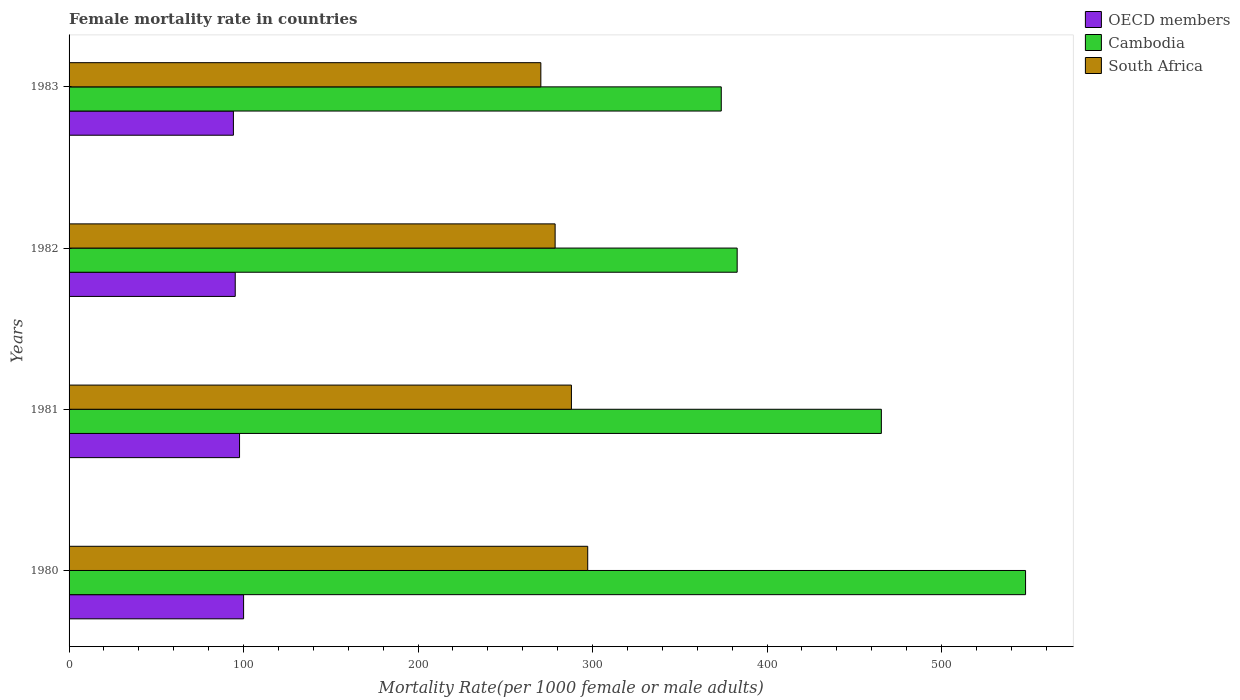Are the number of bars per tick equal to the number of legend labels?
Your answer should be compact. Yes. Are the number of bars on each tick of the Y-axis equal?
Offer a terse response. Yes. What is the label of the 2nd group of bars from the top?
Ensure brevity in your answer.  1982. In how many cases, is the number of bars for a given year not equal to the number of legend labels?
Offer a terse response. 0. What is the female mortality rate in Cambodia in 1983?
Your answer should be very brief. 373.76. Across all years, what is the maximum female mortality rate in South Africa?
Your answer should be compact. 297.23. Across all years, what is the minimum female mortality rate in Cambodia?
Provide a short and direct response. 373.76. What is the total female mortality rate in South Africa in the graph?
Give a very brief answer. 1134.04. What is the difference between the female mortality rate in South Africa in 1981 and that in 1982?
Provide a short and direct response. 9.34. What is the difference between the female mortality rate in South Africa in 1981 and the female mortality rate in Cambodia in 1982?
Give a very brief answer. -94.98. What is the average female mortality rate in South Africa per year?
Give a very brief answer. 283.51. In the year 1981, what is the difference between the female mortality rate in Cambodia and female mortality rate in South Africa?
Ensure brevity in your answer.  177.62. What is the ratio of the female mortality rate in Cambodia in 1980 to that in 1983?
Your answer should be compact. 1.47. Is the female mortality rate in South Africa in 1982 less than that in 1983?
Your answer should be compact. No. What is the difference between the highest and the second highest female mortality rate in South Africa?
Offer a terse response. 9.34. What is the difference between the highest and the lowest female mortality rate in OECD members?
Offer a terse response. 5.83. In how many years, is the female mortality rate in Cambodia greater than the average female mortality rate in Cambodia taken over all years?
Your answer should be compact. 2. Is the sum of the female mortality rate in Cambodia in 1982 and 1983 greater than the maximum female mortality rate in OECD members across all years?
Your response must be concise. Yes. What does the 3rd bar from the top in 1982 represents?
Provide a short and direct response. OECD members. What does the 2nd bar from the bottom in 1981 represents?
Ensure brevity in your answer.  Cambodia. How many bars are there?
Offer a terse response. 12. What is the difference between two consecutive major ticks on the X-axis?
Offer a very short reply. 100. Are the values on the major ticks of X-axis written in scientific E-notation?
Make the answer very short. No. Does the graph contain grids?
Your answer should be very brief. No. Where does the legend appear in the graph?
Ensure brevity in your answer.  Top right. What is the title of the graph?
Your answer should be compact. Female mortality rate in countries. Does "Mauritania" appear as one of the legend labels in the graph?
Provide a short and direct response. No. What is the label or title of the X-axis?
Your answer should be very brief. Mortality Rate(per 1000 female or male adults). What is the label or title of the Y-axis?
Your answer should be very brief. Years. What is the Mortality Rate(per 1000 female or male adults) in OECD members in 1980?
Provide a succinct answer. 100.01. What is the Mortality Rate(per 1000 female or male adults) of Cambodia in 1980?
Your answer should be compact. 548.15. What is the Mortality Rate(per 1000 female or male adults) of South Africa in 1980?
Ensure brevity in your answer.  297.23. What is the Mortality Rate(per 1000 female or male adults) of OECD members in 1981?
Offer a terse response. 97.7. What is the Mortality Rate(per 1000 female or male adults) in Cambodia in 1981?
Offer a very short reply. 465.51. What is the Mortality Rate(per 1000 female or male adults) in South Africa in 1981?
Make the answer very short. 287.89. What is the Mortality Rate(per 1000 female or male adults) of OECD members in 1982?
Ensure brevity in your answer.  95.22. What is the Mortality Rate(per 1000 female or male adults) in Cambodia in 1982?
Keep it short and to the point. 382.88. What is the Mortality Rate(per 1000 female or male adults) in South Africa in 1982?
Provide a succinct answer. 278.55. What is the Mortality Rate(per 1000 female or male adults) in OECD members in 1983?
Offer a very short reply. 94.18. What is the Mortality Rate(per 1000 female or male adults) of Cambodia in 1983?
Give a very brief answer. 373.76. What is the Mortality Rate(per 1000 female or male adults) of South Africa in 1983?
Ensure brevity in your answer.  270.36. Across all years, what is the maximum Mortality Rate(per 1000 female or male adults) of OECD members?
Your response must be concise. 100.01. Across all years, what is the maximum Mortality Rate(per 1000 female or male adults) in Cambodia?
Give a very brief answer. 548.15. Across all years, what is the maximum Mortality Rate(per 1000 female or male adults) of South Africa?
Your response must be concise. 297.23. Across all years, what is the minimum Mortality Rate(per 1000 female or male adults) in OECD members?
Ensure brevity in your answer.  94.18. Across all years, what is the minimum Mortality Rate(per 1000 female or male adults) of Cambodia?
Offer a terse response. 373.76. Across all years, what is the minimum Mortality Rate(per 1000 female or male adults) of South Africa?
Ensure brevity in your answer.  270.36. What is the total Mortality Rate(per 1000 female or male adults) in OECD members in the graph?
Provide a succinct answer. 387.12. What is the total Mortality Rate(per 1000 female or male adults) in Cambodia in the graph?
Keep it short and to the point. 1770.29. What is the total Mortality Rate(per 1000 female or male adults) of South Africa in the graph?
Make the answer very short. 1134.04. What is the difference between the Mortality Rate(per 1000 female or male adults) of OECD members in 1980 and that in 1981?
Offer a terse response. 2.31. What is the difference between the Mortality Rate(per 1000 female or male adults) of Cambodia in 1980 and that in 1981?
Offer a very short reply. 82.64. What is the difference between the Mortality Rate(per 1000 female or male adults) in South Africa in 1980 and that in 1981?
Provide a succinct answer. 9.34. What is the difference between the Mortality Rate(per 1000 female or male adults) in OECD members in 1980 and that in 1982?
Make the answer very short. 4.79. What is the difference between the Mortality Rate(per 1000 female or male adults) of Cambodia in 1980 and that in 1982?
Your response must be concise. 165.27. What is the difference between the Mortality Rate(per 1000 female or male adults) in South Africa in 1980 and that in 1982?
Your answer should be compact. 18.68. What is the difference between the Mortality Rate(per 1000 female or male adults) of OECD members in 1980 and that in 1983?
Make the answer very short. 5.83. What is the difference between the Mortality Rate(per 1000 female or male adults) of Cambodia in 1980 and that in 1983?
Offer a terse response. 174.39. What is the difference between the Mortality Rate(per 1000 female or male adults) in South Africa in 1980 and that in 1983?
Keep it short and to the point. 26.87. What is the difference between the Mortality Rate(per 1000 female or male adults) of OECD members in 1981 and that in 1982?
Give a very brief answer. 2.48. What is the difference between the Mortality Rate(per 1000 female or male adults) in Cambodia in 1981 and that in 1982?
Give a very brief answer. 82.64. What is the difference between the Mortality Rate(per 1000 female or male adults) of South Africa in 1981 and that in 1982?
Provide a succinct answer. 9.34. What is the difference between the Mortality Rate(per 1000 female or male adults) of OECD members in 1981 and that in 1983?
Provide a short and direct response. 3.52. What is the difference between the Mortality Rate(per 1000 female or male adults) of Cambodia in 1981 and that in 1983?
Ensure brevity in your answer.  91.75. What is the difference between the Mortality Rate(per 1000 female or male adults) in South Africa in 1981 and that in 1983?
Offer a very short reply. 17.53. What is the difference between the Mortality Rate(per 1000 female or male adults) of OECD members in 1982 and that in 1983?
Make the answer very short. 1.05. What is the difference between the Mortality Rate(per 1000 female or male adults) in Cambodia in 1982 and that in 1983?
Offer a very short reply. 9.12. What is the difference between the Mortality Rate(per 1000 female or male adults) in South Africa in 1982 and that in 1983?
Ensure brevity in your answer.  8.19. What is the difference between the Mortality Rate(per 1000 female or male adults) in OECD members in 1980 and the Mortality Rate(per 1000 female or male adults) in Cambodia in 1981?
Give a very brief answer. -365.5. What is the difference between the Mortality Rate(per 1000 female or male adults) in OECD members in 1980 and the Mortality Rate(per 1000 female or male adults) in South Africa in 1981?
Provide a succinct answer. -187.88. What is the difference between the Mortality Rate(per 1000 female or male adults) of Cambodia in 1980 and the Mortality Rate(per 1000 female or male adults) of South Africa in 1981?
Your answer should be very brief. 260.25. What is the difference between the Mortality Rate(per 1000 female or male adults) of OECD members in 1980 and the Mortality Rate(per 1000 female or male adults) of Cambodia in 1982?
Provide a succinct answer. -282.86. What is the difference between the Mortality Rate(per 1000 female or male adults) of OECD members in 1980 and the Mortality Rate(per 1000 female or male adults) of South Africa in 1982?
Your response must be concise. -178.54. What is the difference between the Mortality Rate(per 1000 female or male adults) in Cambodia in 1980 and the Mortality Rate(per 1000 female or male adults) in South Africa in 1982?
Your response must be concise. 269.6. What is the difference between the Mortality Rate(per 1000 female or male adults) of OECD members in 1980 and the Mortality Rate(per 1000 female or male adults) of Cambodia in 1983?
Offer a terse response. -273.74. What is the difference between the Mortality Rate(per 1000 female or male adults) of OECD members in 1980 and the Mortality Rate(per 1000 female or male adults) of South Africa in 1983?
Your response must be concise. -170.35. What is the difference between the Mortality Rate(per 1000 female or male adults) of Cambodia in 1980 and the Mortality Rate(per 1000 female or male adults) of South Africa in 1983?
Your answer should be very brief. 277.78. What is the difference between the Mortality Rate(per 1000 female or male adults) of OECD members in 1981 and the Mortality Rate(per 1000 female or male adults) of Cambodia in 1982?
Give a very brief answer. -285.18. What is the difference between the Mortality Rate(per 1000 female or male adults) of OECD members in 1981 and the Mortality Rate(per 1000 female or male adults) of South Africa in 1982?
Provide a succinct answer. -180.85. What is the difference between the Mortality Rate(per 1000 female or male adults) in Cambodia in 1981 and the Mortality Rate(per 1000 female or male adults) in South Africa in 1982?
Give a very brief answer. 186.96. What is the difference between the Mortality Rate(per 1000 female or male adults) of OECD members in 1981 and the Mortality Rate(per 1000 female or male adults) of Cambodia in 1983?
Ensure brevity in your answer.  -276.06. What is the difference between the Mortality Rate(per 1000 female or male adults) in OECD members in 1981 and the Mortality Rate(per 1000 female or male adults) in South Africa in 1983?
Make the answer very short. -172.66. What is the difference between the Mortality Rate(per 1000 female or male adults) in Cambodia in 1981 and the Mortality Rate(per 1000 female or male adults) in South Africa in 1983?
Offer a very short reply. 195.15. What is the difference between the Mortality Rate(per 1000 female or male adults) of OECD members in 1982 and the Mortality Rate(per 1000 female or male adults) of Cambodia in 1983?
Offer a terse response. -278.53. What is the difference between the Mortality Rate(per 1000 female or male adults) of OECD members in 1982 and the Mortality Rate(per 1000 female or male adults) of South Africa in 1983?
Provide a succinct answer. -175.14. What is the difference between the Mortality Rate(per 1000 female or male adults) in Cambodia in 1982 and the Mortality Rate(per 1000 female or male adults) in South Africa in 1983?
Make the answer very short. 112.51. What is the average Mortality Rate(per 1000 female or male adults) in OECD members per year?
Offer a terse response. 96.78. What is the average Mortality Rate(per 1000 female or male adults) of Cambodia per year?
Keep it short and to the point. 442.57. What is the average Mortality Rate(per 1000 female or male adults) of South Africa per year?
Your response must be concise. 283.51. In the year 1980, what is the difference between the Mortality Rate(per 1000 female or male adults) of OECD members and Mortality Rate(per 1000 female or male adults) of Cambodia?
Your answer should be very brief. -448.13. In the year 1980, what is the difference between the Mortality Rate(per 1000 female or male adults) of OECD members and Mortality Rate(per 1000 female or male adults) of South Africa?
Offer a very short reply. -197.22. In the year 1980, what is the difference between the Mortality Rate(per 1000 female or male adults) in Cambodia and Mortality Rate(per 1000 female or male adults) in South Africa?
Your answer should be compact. 250.91. In the year 1981, what is the difference between the Mortality Rate(per 1000 female or male adults) of OECD members and Mortality Rate(per 1000 female or male adults) of Cambodia?
Your answer should be very brief. -367.81. In the year 1981, what is the difference between the Mortality Rate(per 1000 female or male adults) in OECD members and Mortality Rate(per 1000 female or male adults) in South Africa?
Provide a short and direct response. -190.19. In the year 1981, what is the difference between the Mortality Rate(per 1000 female or male adults) of Cambodia and Mortality Rate(per 1000 female or male adults) of South Africa?
Your response must be concise. 177.62. In the year 1982, what is the difference between the Mortality Rate(per 1000 female or male adults) of OECD members and Mortality Rate(per 1000 female or male adults) of Cambodia?
Offer a very short reply. -287.65. In the year 1982, what is the difference between the Mortality Rate(per 1000 female or male adults) in OECD members and Mortality Rate(per 1000 female or male adults) in South Africa?
Keep it short and to the point. -183.33. In the year 1982, what is the difference between the Mortality Rate(per 1000 female or male adults) of Cambodia and Mortality Rate(per 1000 female or male adults) of South Africa?
Provide a short and direct response. 104.32. In the year 1983, what is the difference between the Mortality Rate(per 1000 female or male adults) in OECD members and Mortality Rate(per 1000 female or male adults) in Cambodia?
Your answer should be very brief. -279.58. In the year 1983, what is the difference between the Mortality Rate(per 1000 female or male adults) of OECD members and Mortality Rate(per 1000 female or male adults) of South Africa?
Keep it short and to the point. -176.19. In the year 1983, what is the difference between the Mortality Rate(per 1000 female or male adults) of Cambodia and Mortality Rate(per 1000 female or male adults) of South Africa?
Ensure brevity in your answer.  103.39. What is the ratio of the Mortality Rate(per 1000 female or male adults) of OECD members in 1980 to that in 1981?
Make the answer very short. 1.02. What is the ratio of the Mortality Rate(per 1000 female or male adults) in Cambodia in 1980 to that in 1981?
Your answer should be very brief. 1.18. What is the ratio of the Mortality Rate(per 1000 female or male adults) in South Africa in 1980 to that in 1981?
Your answer should be very brief. 1.03. What is the ratio of the Mortality Rate(per 1000 female or male adults) of OECD members in 1980 to that in 1982?
Provide a short and direct response. 1.05. What is the ratio of the Mortality Rate(per 1000 female or male adults) in Cambodia in 1980 to that in 1982?
Ensure brevity in your answer.  1.43. What is the ratio of the Mortality Rate(per 1000 female or male adults) of South Africa in 1980 to that in 1982?
Keep it short and to the point. 1.07. What is the ratio of the Mortality Rate(per 1000 female or male adults) in OECD members in 1980 to that in 1983?
Offer a very short reply. 1.06. What is the ratio of the Mortality Rate(per 1000 female or male adults) of Cambodia in 1980 to that in 1983?
Make the answer very short. 1.47. What is the ratio of the Mortality Rate(per 1000 female or male adults) of South Africa in 1980 to that in 1983?
Provide a succinct answer. 1.1. What is the ratio of the Mortality Rate(per 1000 female or male adults) in OECD members in 1981 to that in 1982?
Provide a succinct answer. 1.03. What is the ratio of the Mortality Rate(per 1000 female or male adults) of Cambodia in 1981 to that in 1982?
Make the answer very short. 1.22. What is the ratio of the Mortality Rate(per 1000 female or male adults) in South Africa in 1981 to that in 1982?
Keep it short and to the point. 1.03. What is the ratio of the Mortality Rate(per 1000 female or male adults) in OECD members in 1981 to that in 1983?
Your answer should be compact. 1.04. What is the ratio of the Mortality Rate(per 1000 female or male adults) of Cambodia in 1981 to that in 1983?
Give a very brief answer. 1.25. What is the ratio of the Mortality Rate(per 1000 female or male adults) of South Africa in 1981 to that in 1983?
Make the answer very short. 1.06. What is the ratio of the Mortality Rate(per 1000 female or male adults) in OECD members in 1982 to that in 1983?
Your answer should be very brief. 1.01. What is the ratio of the Mortality Rate(per 1000 female or male adults) in Cambodia in 1982 to that in 1983?
Ensure brevity in your answer.  1.02. What is the ratio of the Mortality Rate(per 1000 female or male adults) of South Africa in 1982 to that in 1983?
Your response must be concise. 1.03. What is the difference between the highest and the second highest Mortality Rate(per 1000 female or male adults) of OECD members?
Provide a succinct answer. 2.31. What is the difference between the highest and the second highest Mortality Rate(per 1000 female or male adults) of Cambodia?
Offer a terse response. 82.64. What is the difference between the highest and the second highest Mortality Rate(per 1000 female or male adults) of South Africa?
Your response must be concise. 9.34. What is the difference between the highest and the lowest Mortality Rate(per 1000 female or male adults) in OECD members?
Give a very brief answer. 5.83. What is the difference between the highest and the lowest Mortality Rate(per 1000 female or male adults) of Cambodia?
Provide a succinct answer. 174.39. What is the difference between the highest and the lowest Mortality Rate(per 1000 female or male adults) of South Africa?
Your response must be concise. 26.87. 